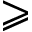Convert formula to latex. <formula><loc_0><loc_0><loc_500><loc_500>\geqslant</formula> 